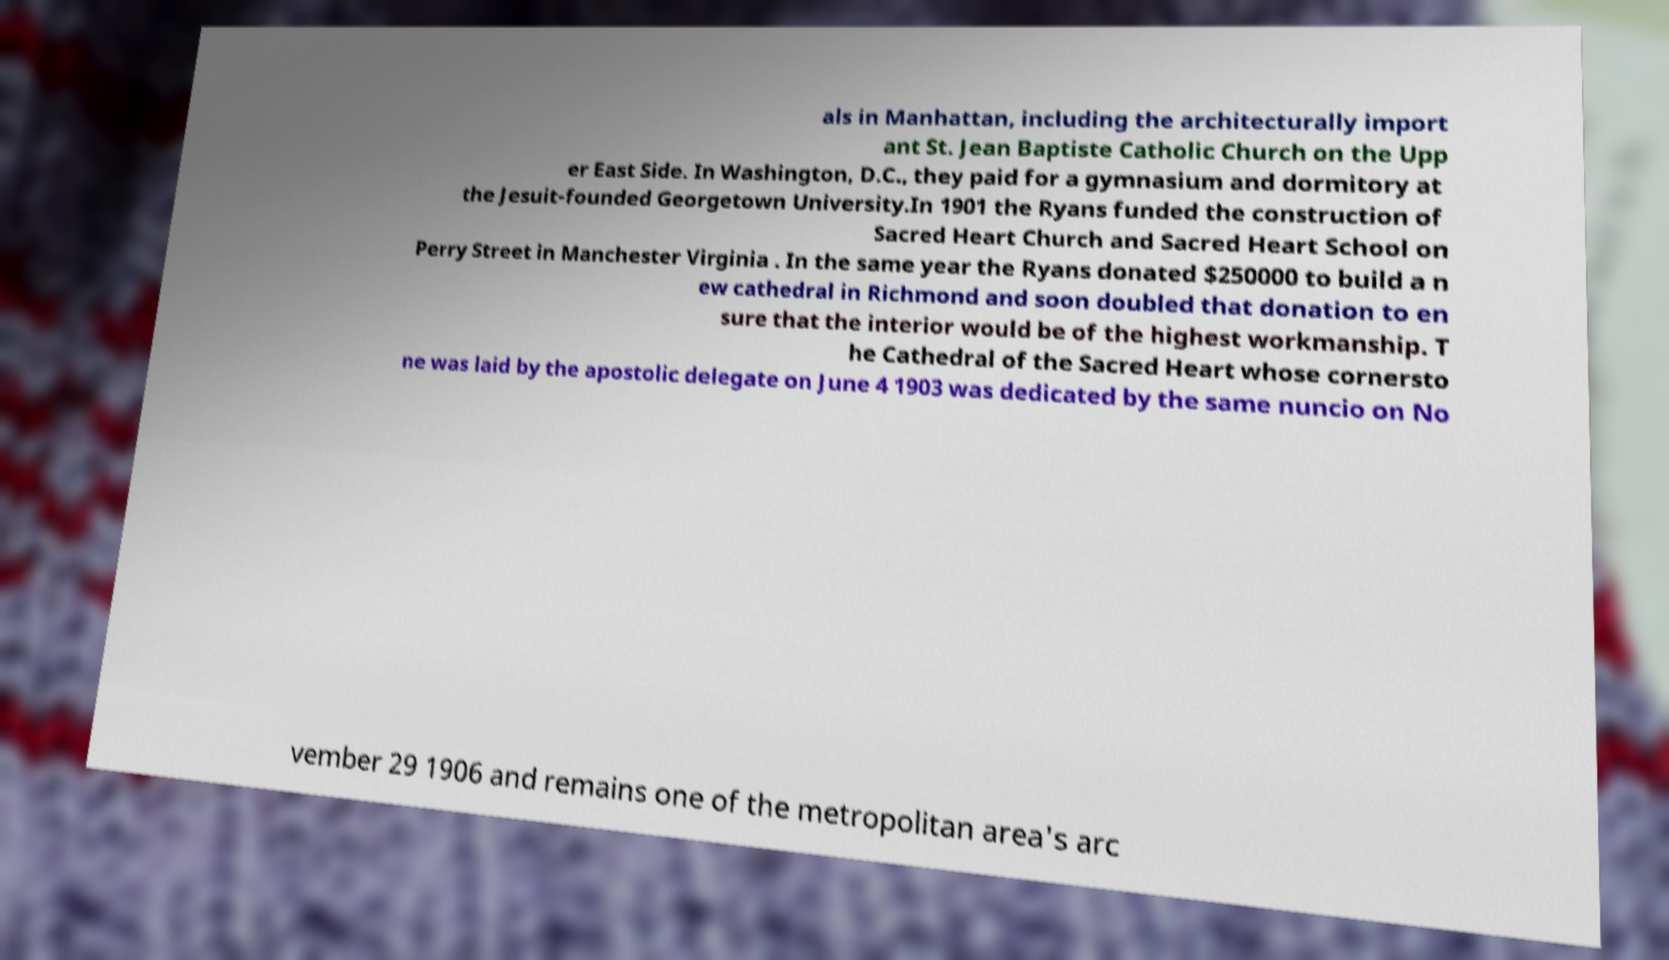Could you extract and type out the text from this image? als in Manhattan, including the architecturally import ant St. Jean Baptiste Catholic Church on the Upp er East Side. In Washington, D.C., they paid for a gymnasium and dormitory at the Jesuit-founded Georgetown University.In 1901 the Ryans funded the construction of Sacred Heart Church and Sacred Heart School on Perry Street in Manchester Virginia . In the same year the Ryans donated $250000 to build a n ew cathedral in Richmond and soon doubled that donation to en sure that the interior would be of the highest workmanship. T he Cathedral of the Sacred Heart whose cornersto ne was laid by the apostolic delegate on June 4 1903 was dedicated by the same nuncio on No vember 29 1906 and remains one of the metropolitan area's arc 